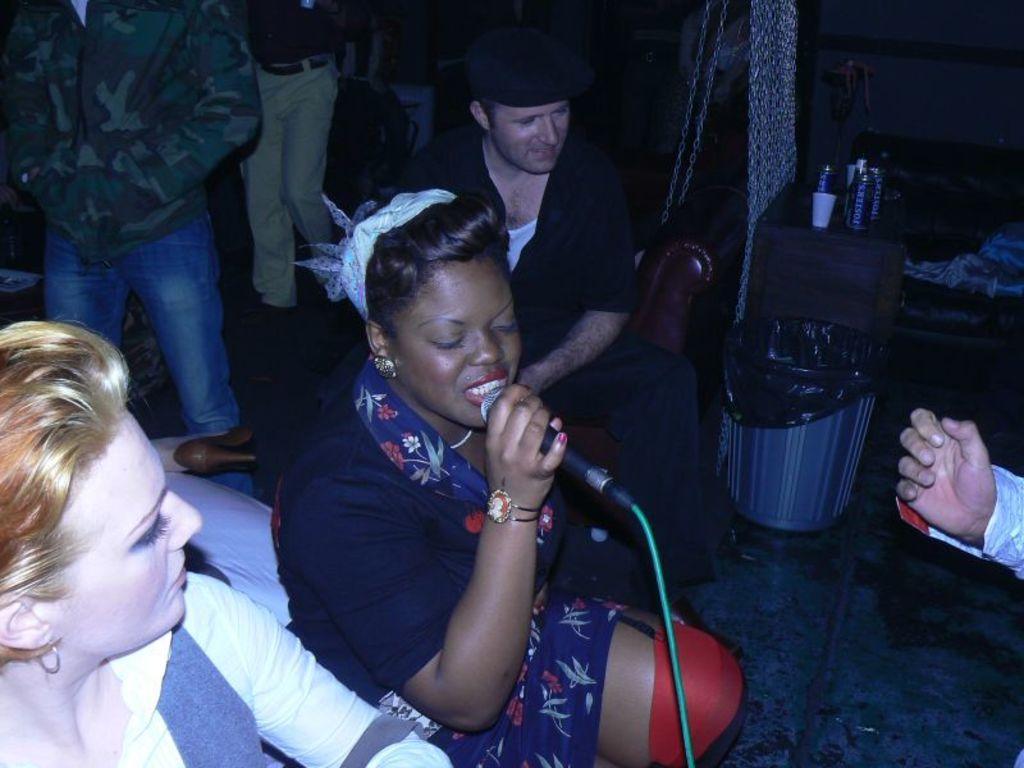Can you describe this image briefly? In this picture I can see number of people in which this woman who is in middle of this picture is holding a mic in her hand and on the right of this image I see a table on which there are few things and I see that it is a bit dark in the background. 